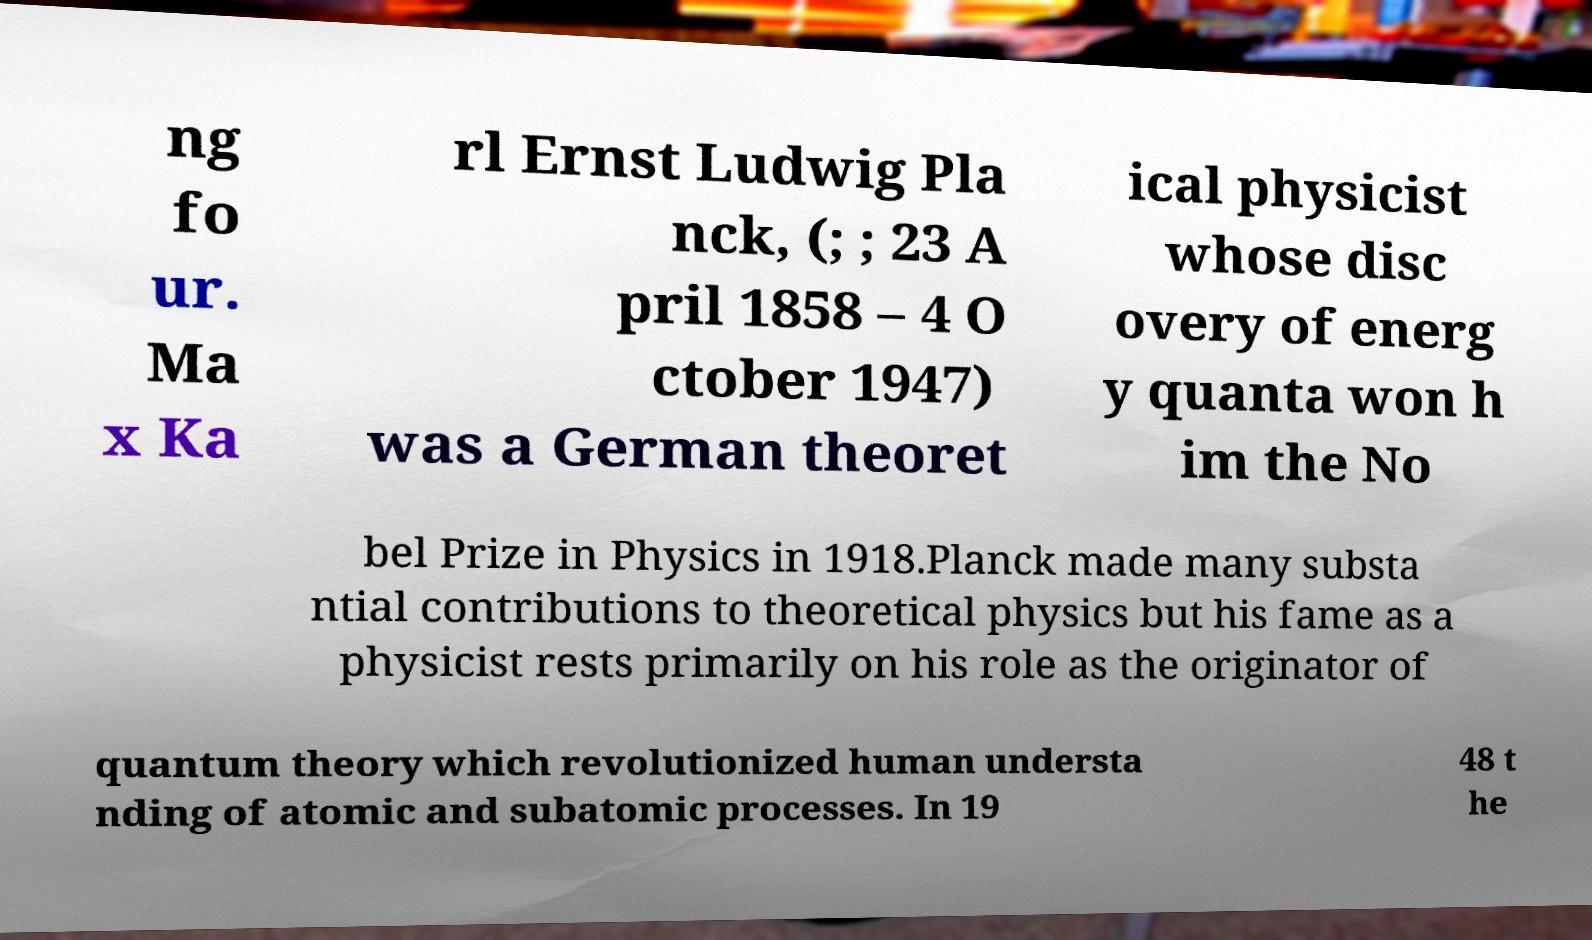Could you assist in decoding the text presented in this image and type it out clearly? ng fo ur. Ma x Ka rl Ernst Ludwig Pla nck, (; ; 23 A pril 1858 – 4 O ctober 1947) was a German theoret ical physicist whose disc overy of energ y quanta won h im the No bel Prize in Physics in 1918.Planck made many substa ntial contributions to theoretical physics but his fame as a physicist rests primarily on his role as the originator of quantum theory which revolutionized human understa nding of atomic and subatomic processes. In 19 48 t he 